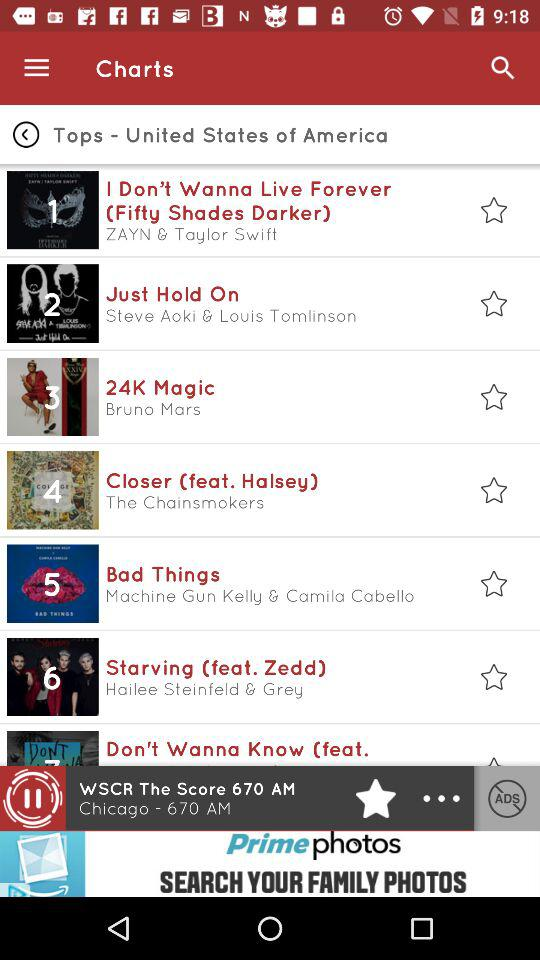What is the name of the country shown in the "Tops"? The name of the country shown in the "Tops" is the United States of America. 